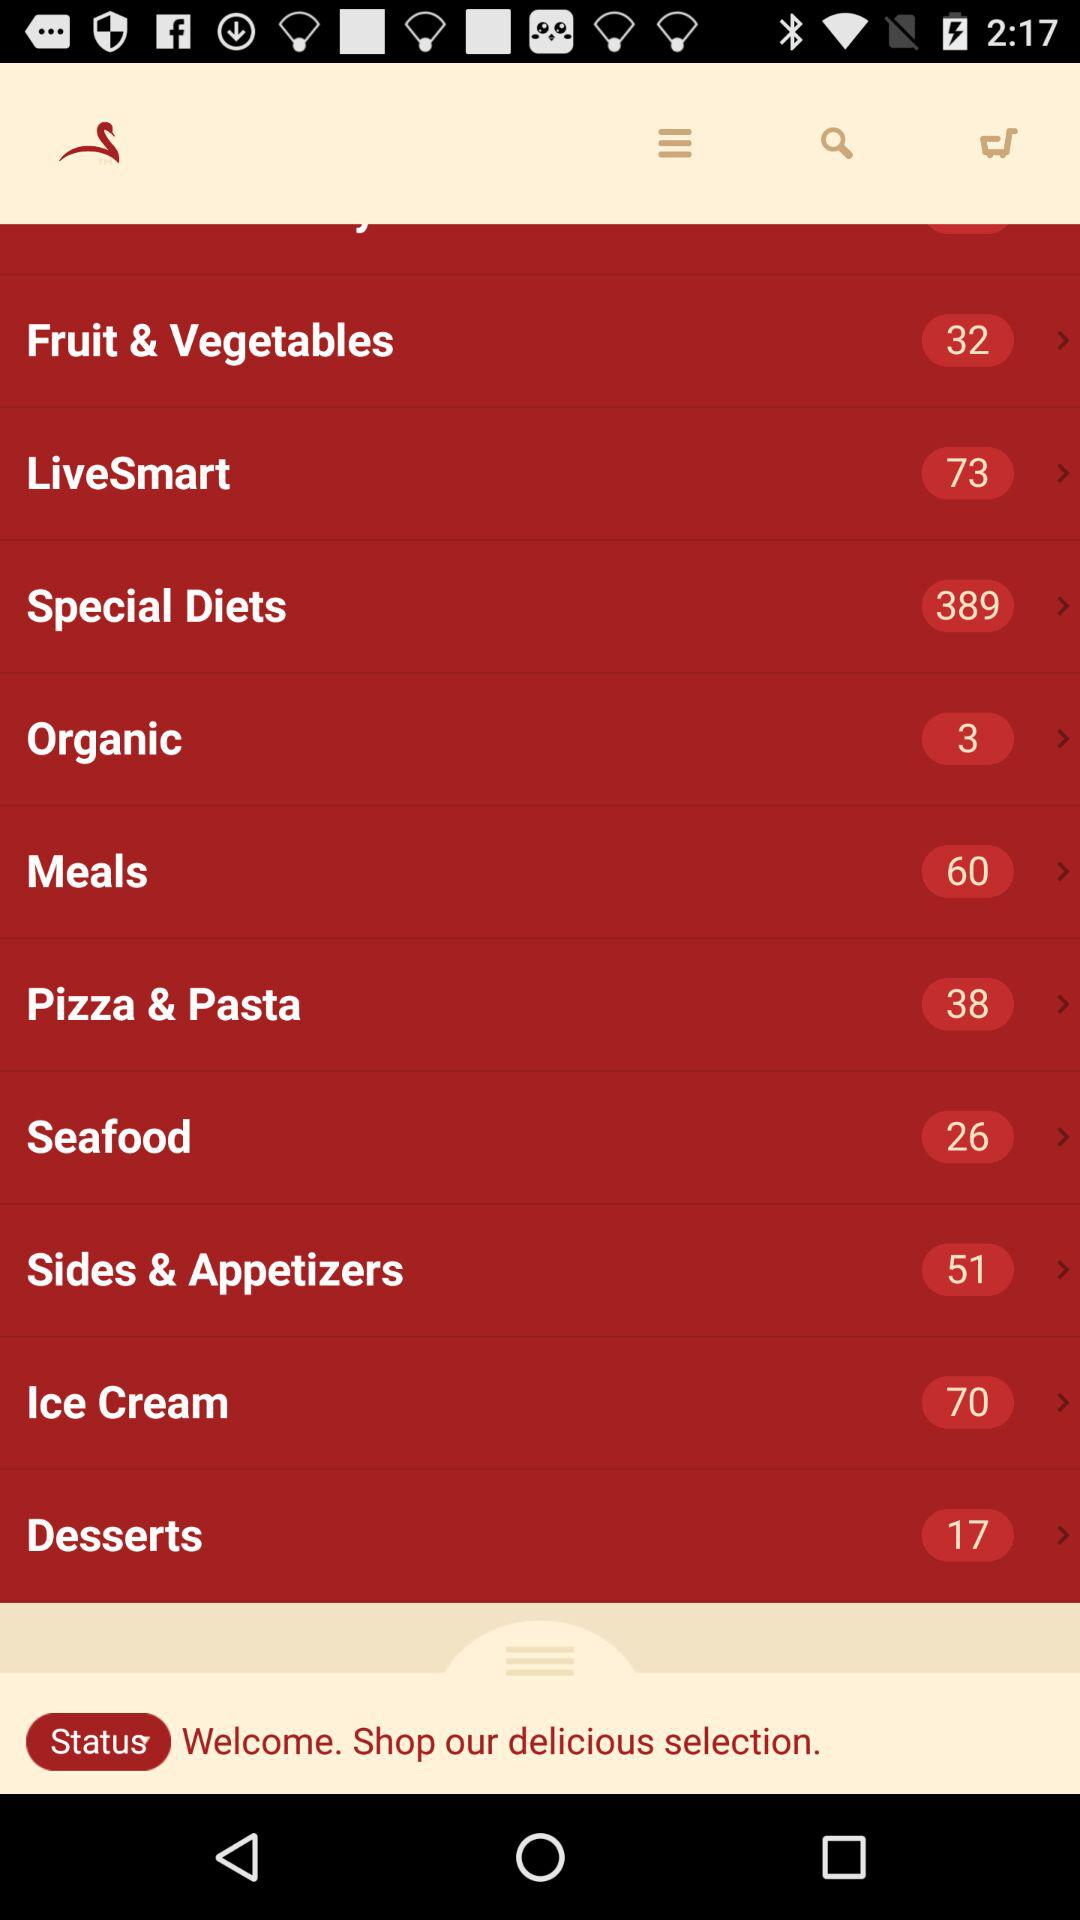What is the total number of "Ice Cream" available? The total number of "Ice Cream" is 70. 